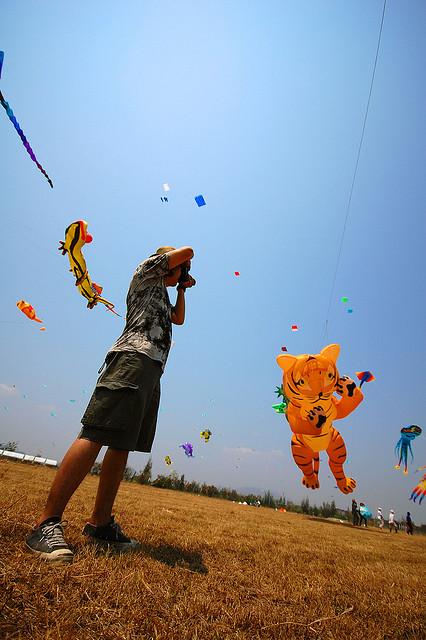Are these balloons or kites?
Quick response, please. Kites. What kind of shoes is the person wearing?
Answer briefly. Sneakers. What animal is seen in the air?
Concise answer only. Tiger. 